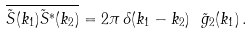<formula> <loc_0><loc_0><loc_500><loc_500>\overline { \tilde { S } ( k _ { 1 } ) \tilde { S } ^ { \ast } ( k _ { 2 } ) } = 2 \pi \, \delta ( k _ { 1 } - k _ { 2 } ) \ \tilde { g } _ { 2 } ( k _ { 1 } ) \, .</formula> 